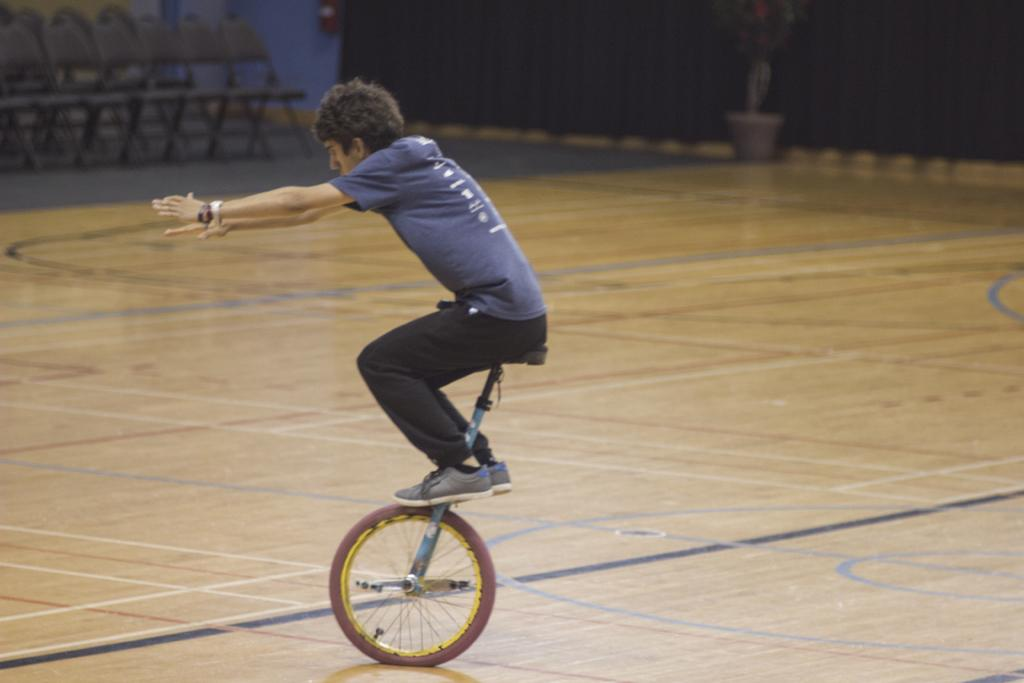What is the main activity being performed by the person in the image? The person is riding a unicycle in the image. What can be seen in the background of the image? There are chairs, an oxygen cylinder, and a plant in the background of the image. What type of letter is being delivered by the birds in the image? There are no birds present in the image, so no letter is being delivered. What emotion does the person riding the unicycle display in the image? The provided facts do not mention any emotions or expressions of the person riding the unicycle, so it cannot be determined from the image. 